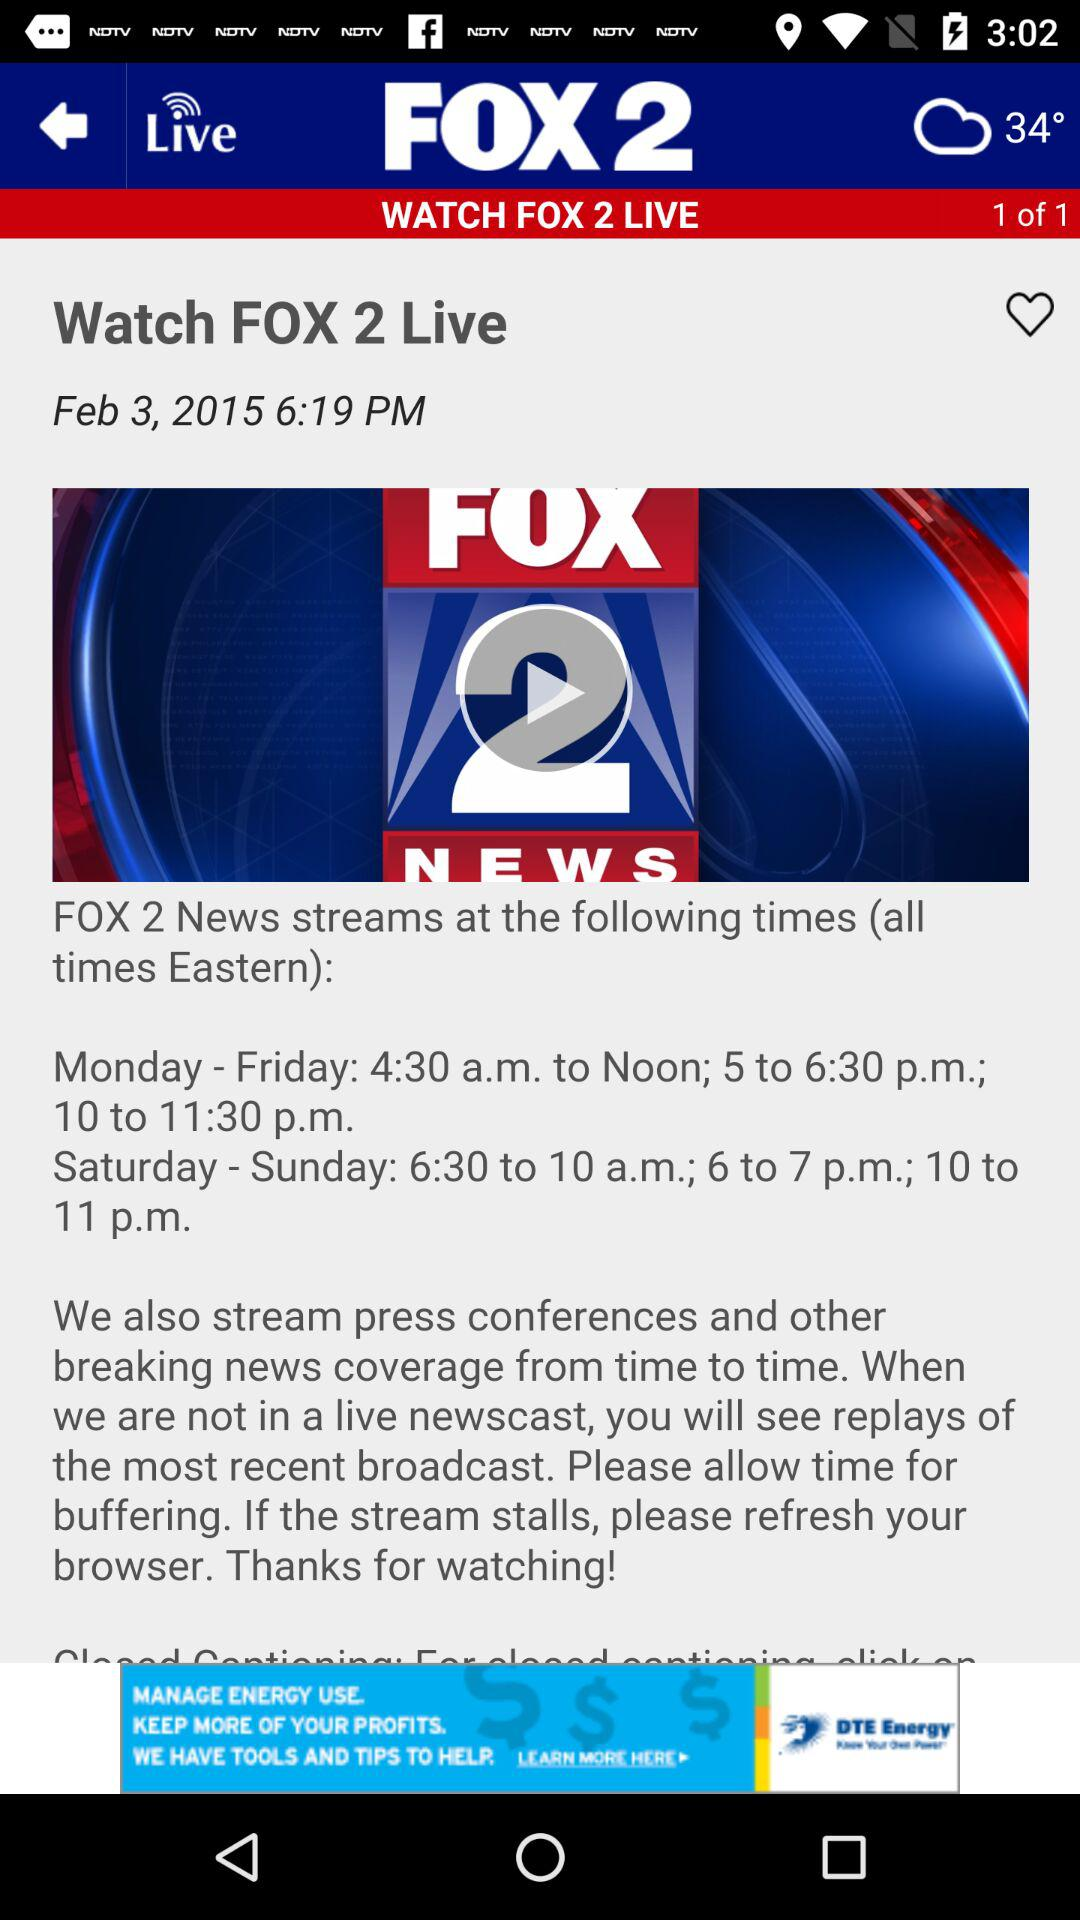What is the streaming time from Monday to Friday? The streaming times from Monday to Friday are 4:30 a.m. to noon, 5 to 6:30 p.m. and 10 to 11:30 p.m. 